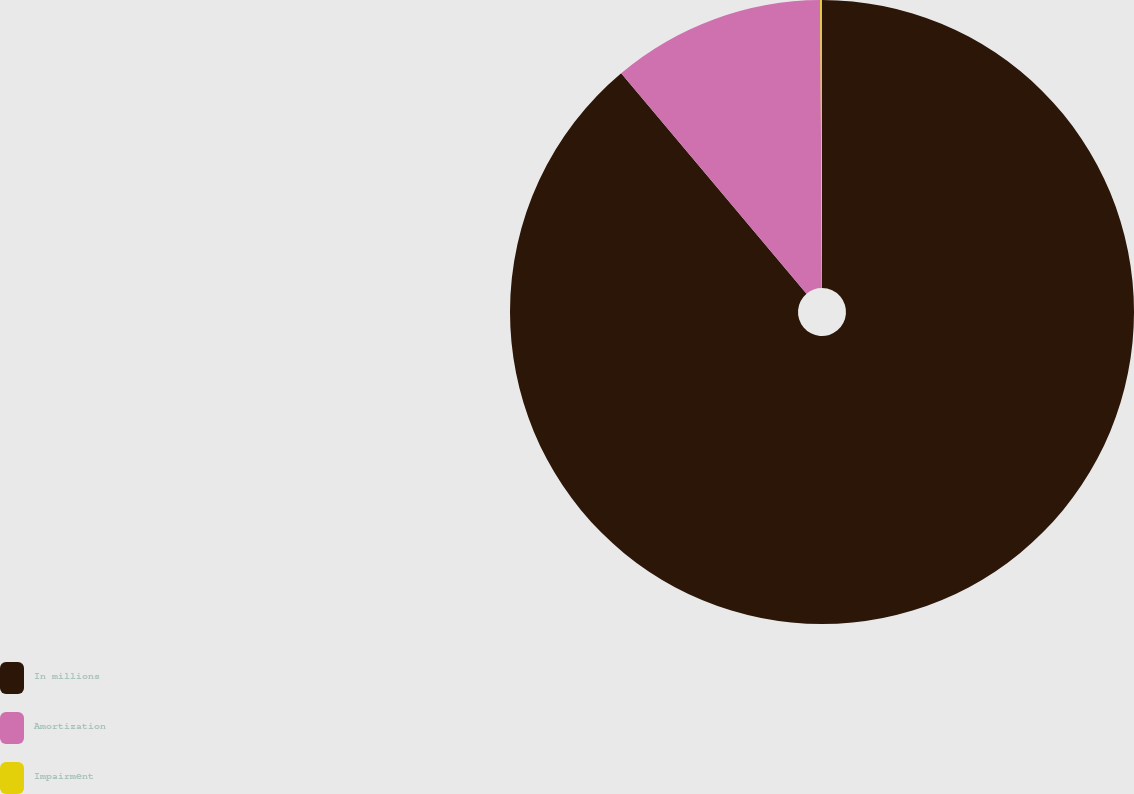<chart> <loc_0><loc_0><loc_500><loc_500><pie_chart><fcel>In millions<fcel>Amortization<fcel>Impairment<nl><fcel>88.87%<fcel>11.04%<fcel>0.09%<nl></chart> 